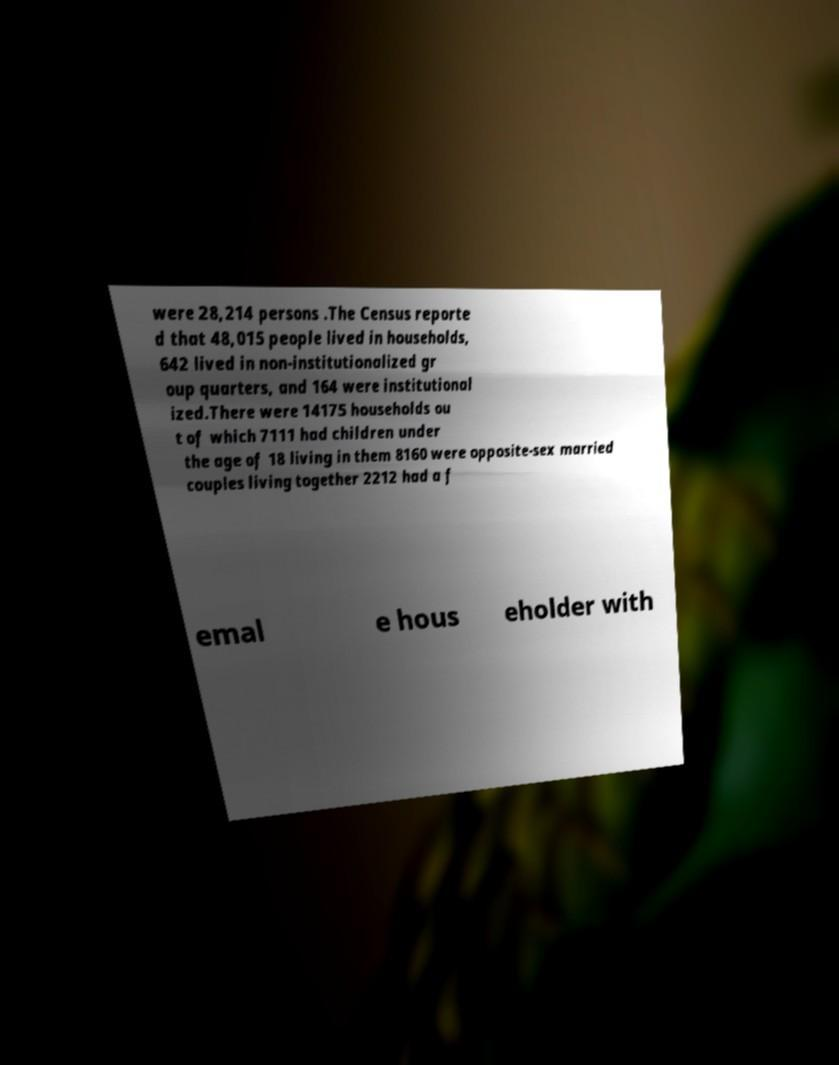Please identify and transcribe the text found in this image. were 28,214 persons .The Census reporte d that 48,015 people lived in households, 642 lived in non-institutionalized gr oup quarters, and 164 were institutional ized.There were 14175 households ou t of which 7111 had children under the age of 18 living in them 8160 were opposite-sex married couples living together 2212 had a f emal e hous eholder with 